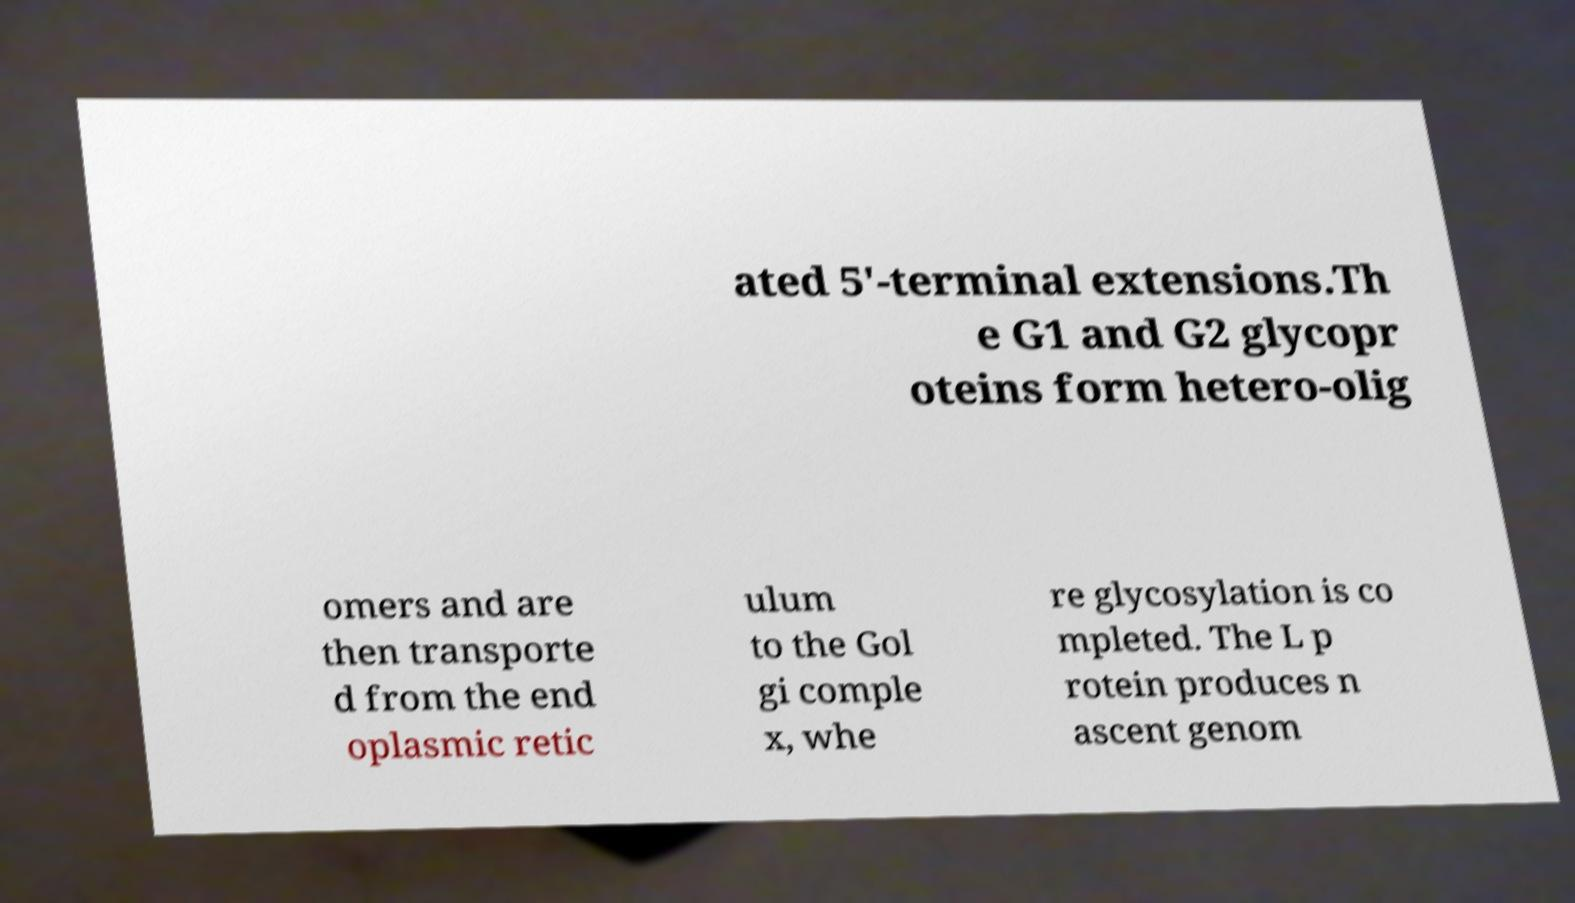There's text embedded in this image that I need extracted. Can you transcribe it verbatim? ated 5'-terminal extensions.Th e G1 and G2 glycopr oteins form hetero-olig omers and are then transporte d from the end oplasmic retic ulum to the Gol gi comple x, whe re glycosylation is co mpleted. The L p rotein produces n ascent genom 